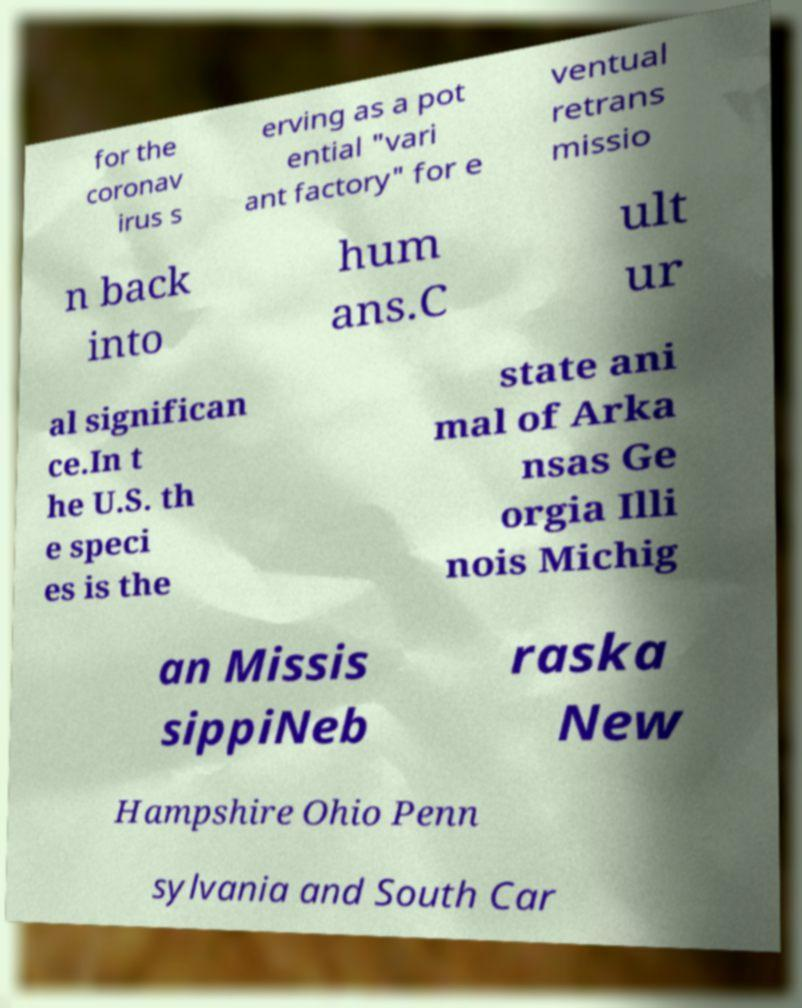Can you accurately transcribe the text from the provided image for me? for the coronav irus s erving as a pot ential "vari ant factory" for e ventual retrans missio n back into hum ans.C ult ur al significan ce.In t he U.S. th e speci es is the state ani mal of Arka nsas Ge orgia Illi nois Michig an Missis sippiNeb raska New Hampshire Ohio Penn sylvania and South Car 